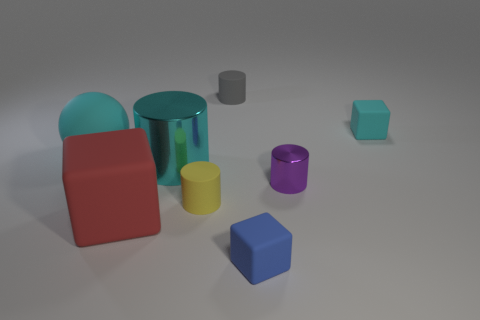Is the color of the rubber object behind the tiny cyan matte cube the same as the shiny cylinder that is in front of the cyan metal object?
Offer a terse response. No. What number of red objects are tiny rubber objects or big rubber blocks?
Offer a terse response. 1. How many green metallic spheres are the same size as the purple cylinder?
Provide a short and direct response. 0. Is the material of the sphere that is behind the purple thing the same as the purple thing?
Provide a short and direct response. No. There is a cyan matte ball behind the red rubber block; is there a small gray matte thing behind it?
Your answer should be compact. Yes. There is a tiny purple thing that is the same shape as the small yellow thing; what is its material?
Keep it short and to the point. Metal. Are there more tiny shiny objects to the right of the yellow rubber object than objects that are to the left of the purple thing?
Your answer should be compact. No. The other cyan object that is made of the same material as the tiny cyan thing is what shape?
Make the answer very short. Sphere. Is the number of cyan matte cubes that are left of the big red rubber thing greater than the number of tiny yellow balls?
Provide a succinct answer. No. How many rubber balls have the same color as the large shiny thing?
Your answer should be very brief. 1. 